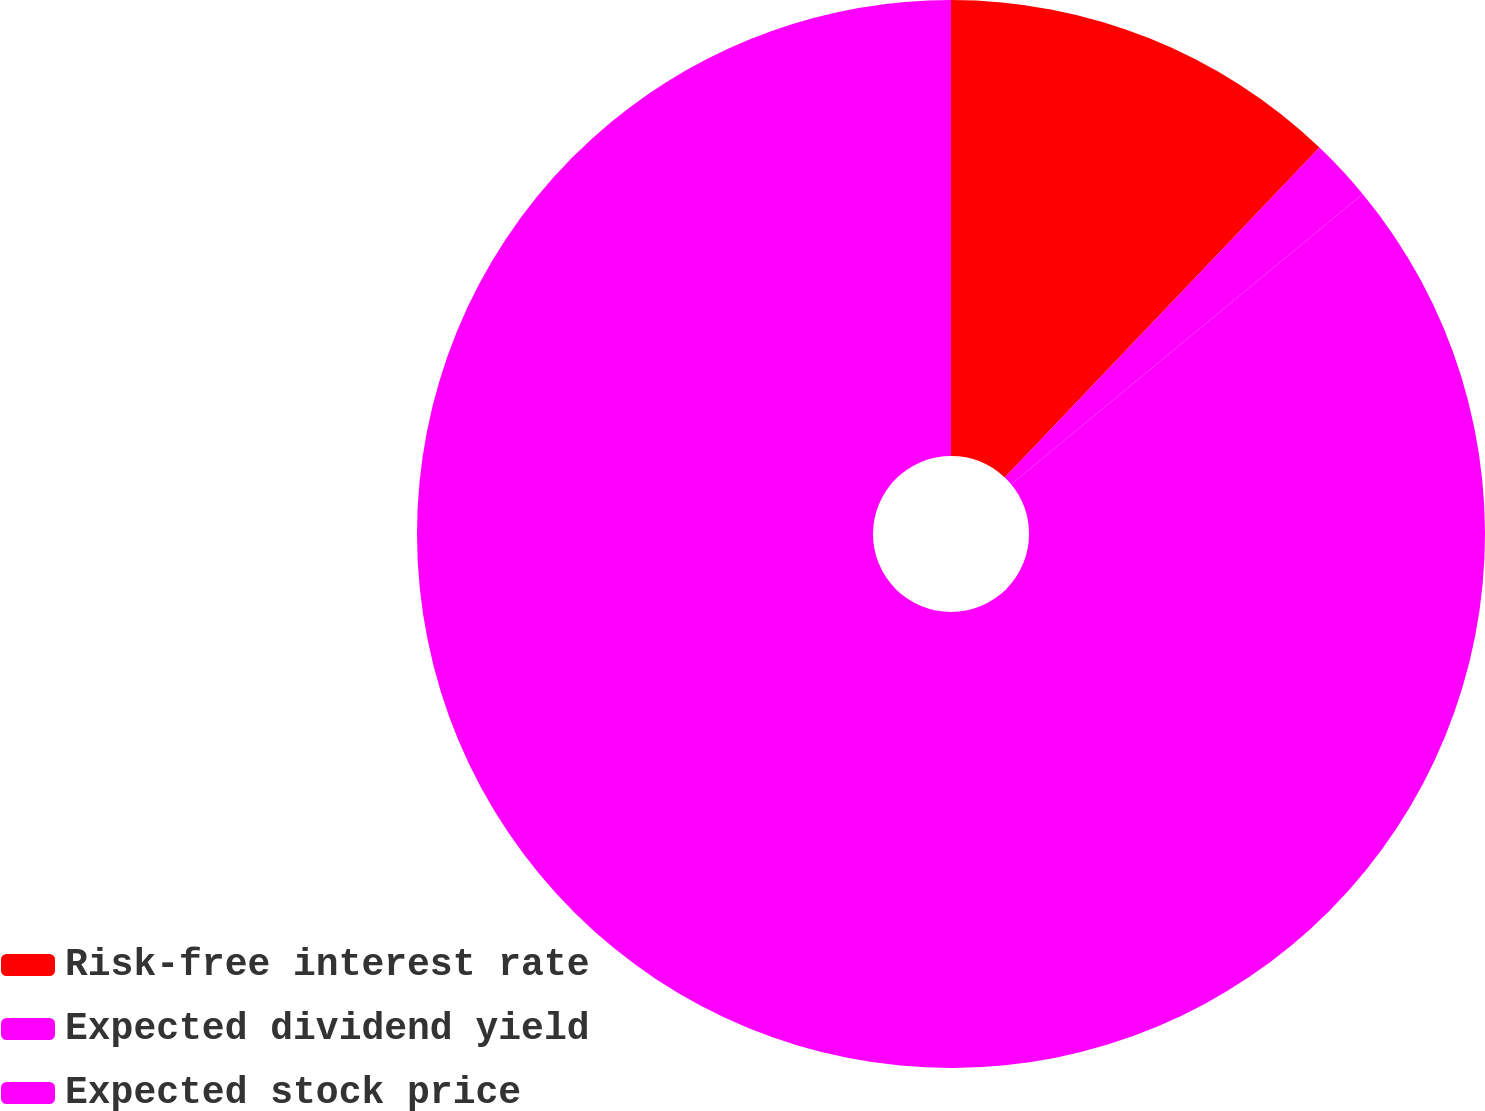Convert chart to OTSL. <chart><loc_0><loc_0><loc_500><loc_500><pie_chart><fcel>Risk-free interest rate<fcel>Expected dividend yield<fcel>Expected stock price<nl><fcel>12.12%<fcel>1.89%<fcel>85.98%<nl></chart> 